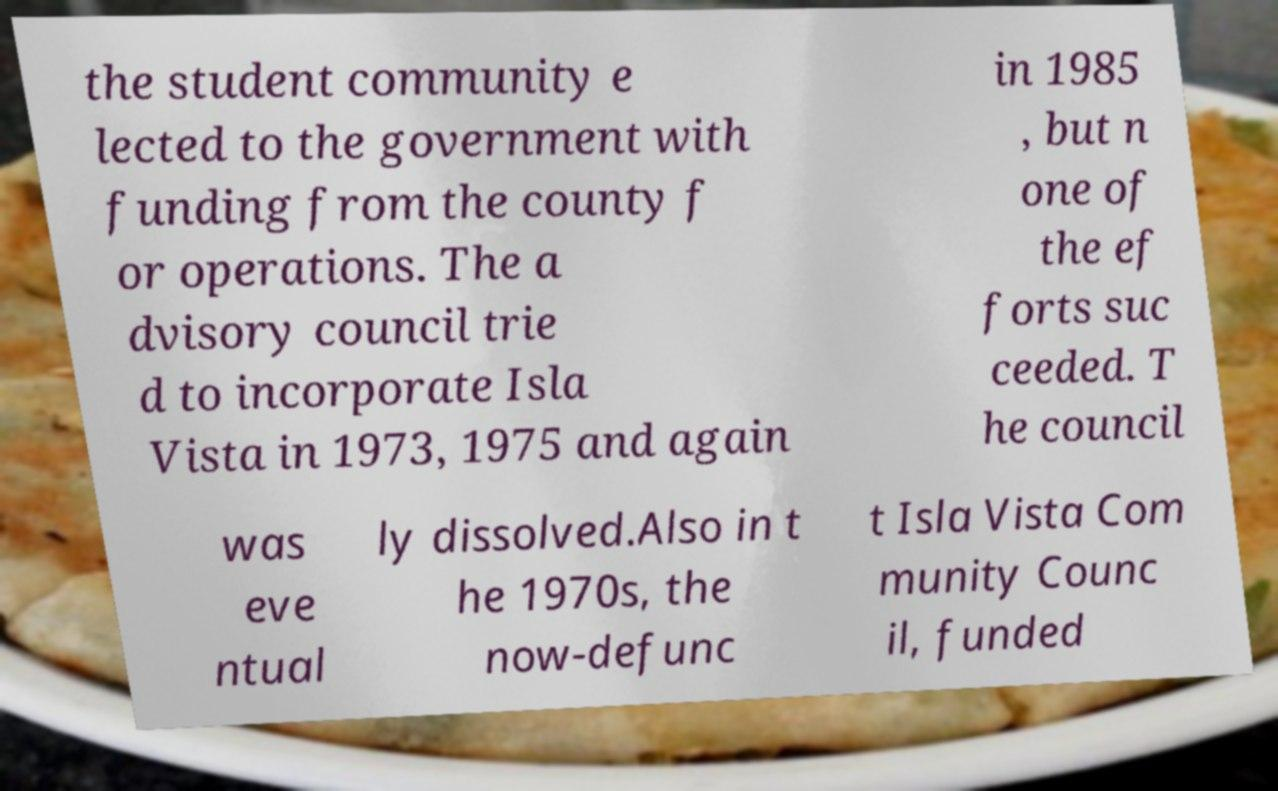Please read and relay the text visible in this image. What does it say? the student community e lected to the government with funding from the county f or operations. The a dvisory council trie d to incorporate Isla Vista in 1973, 1975 and again in 1985 , but n one of the ef forts suc ceeded. T he council was eve ntual ly dissolved.Also in t he 1970s, the now-defunc t Isla Vista Com munity Counc il, funded 